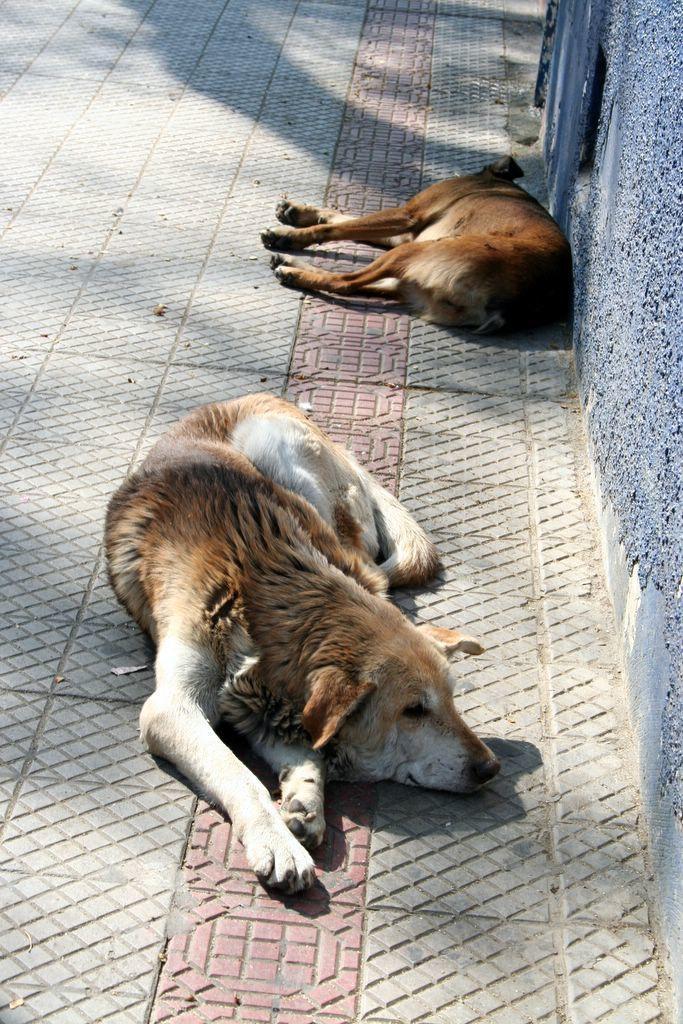Please provide a concise description of this image. In the picture we can see a path on it we can see two dogs are sleeping and near it we can see a wall which is purple in color. 